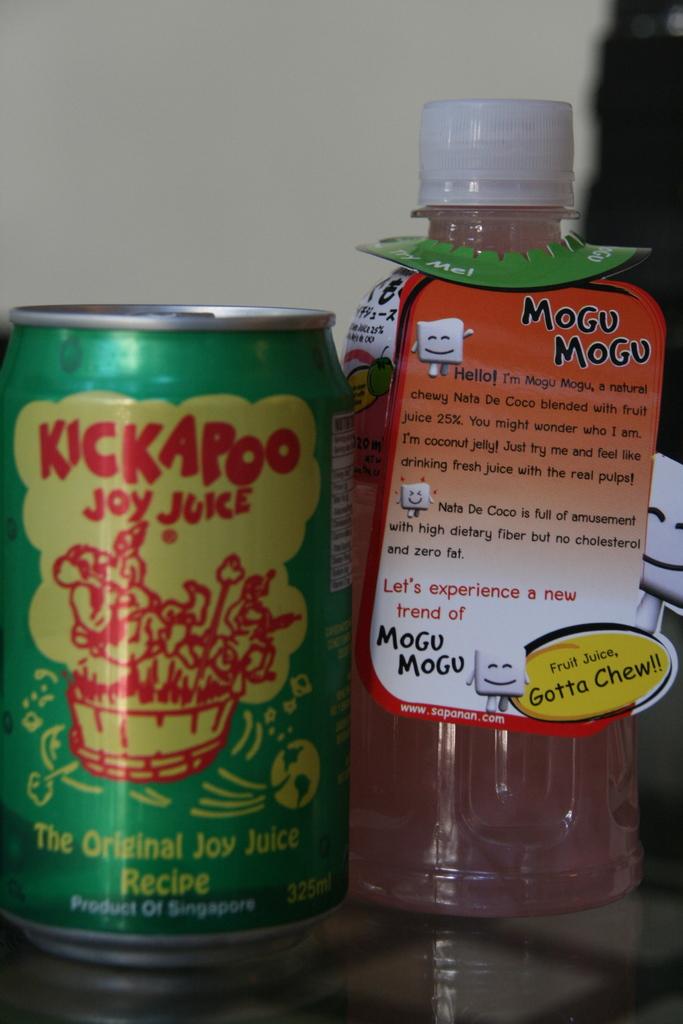What is the name of the product in the can?
Provide a short and direct response. Kickapoo joy juice. 